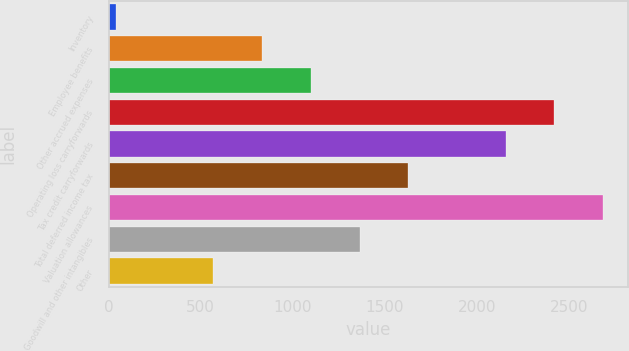Convert chart to OTSL. <chart><loc_0><loc_0><loc_500><loc_500><bar_chart><fcel>Inventory<fcel>Employee benefits<fcel>Other accrued expenses<fcel>Operating loss carryforwards<fcel>Tax credit carryforwards<fcel>Total deferred income tax<fcel>Valuation allowances<fcel>Goodwill and other intangibles<fcel>Other<nl><fcel>41<fcel>834.2<fcel>1098.6<fcel>2420.6<fcel>2156.2<fcel>1627.4<fcel>2685<fcel>1363<fcel>569.8<nl></chart> 